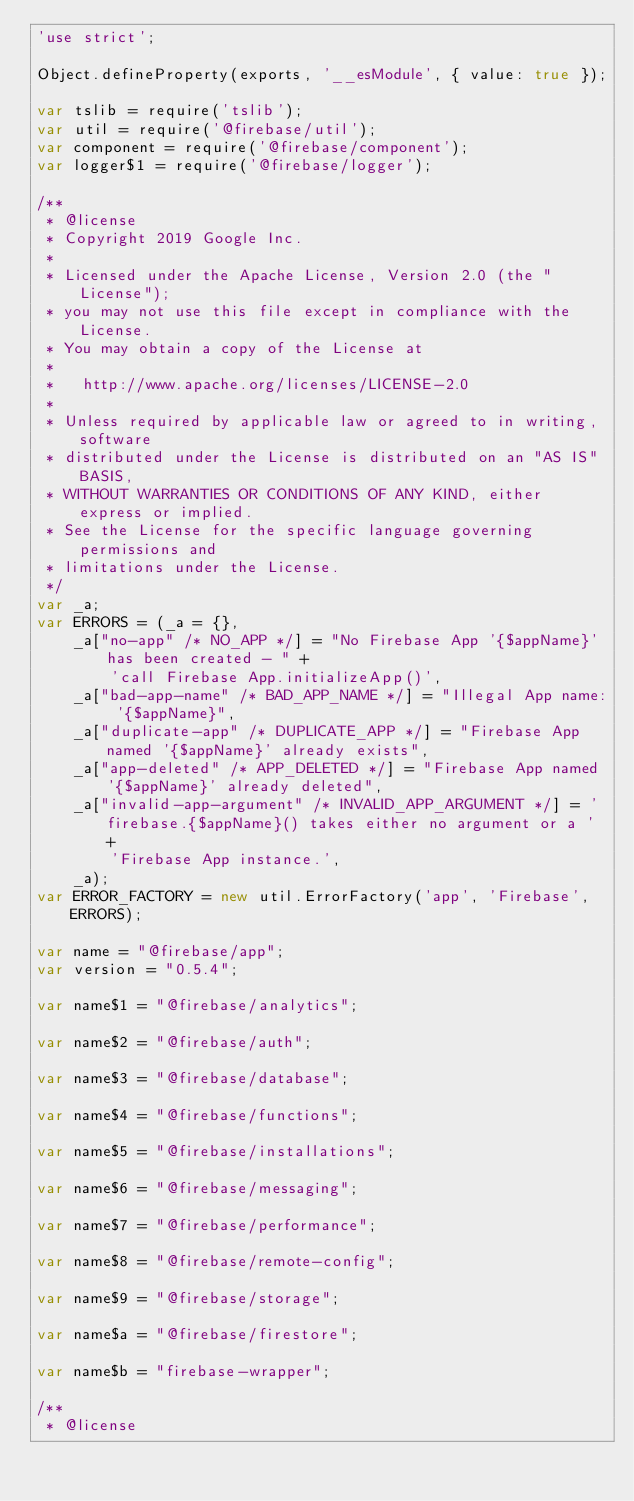<code> <loc_0><loc_0><loc_500><loc_500><_JavaScript_>'use strict';

Object.defineProperty(exports, '__esModule', { value: true });

var tslib = require('tslib');
var util = require('@firebase/util');
var component = require('@firebase/component');
var logger$1 = require('@firebase/logger');

/**
 * @license
 * Copyright 2019 Google Inc.
 *
 * Licensed under the Apache License, Version 2.0 (the "License");
 * you may not use this file except in compliance with the License.
 * You may obtain a copy of the License at
 *
 *   http://www.apache.org/licenses/LICENSE-2.0
 *
 * Unless required by applicable law or agreed to in writing, software
 * distributed under the License is distributed on an "AS IS" BASIS,
 * WITHOUT WARRANTIES OR CONDITIONS OF ANY KIND, either express or implied.
 * See the License for the specific language governing permissions and
 * limitations under the License.
 */
var _a;
var ERRORS = (_a = {},
    _a["no-app" /* NO_APP */] = "No Firebase App '{$appName}' has been created - " +
        'call Firebase App.initializeApp()',
    _a["bad-app-name" /* BAD_APP_NAME */] = "Illegal App name: '{$appName}",
    _a["duplicate-app" /* DUPLICATE_APP */] = "Firebase App named '{$appName}' already exists",
    _a["app-deleted" /* APP_DELETED */] = "Firebase App named '{$appName}' already deleted",
    _a["invalid-app-argument" /* INVALID_APP_ARGUMENT */] = 'firebase.{$appName}() takes either no argument or a ' +
        'Firebase App instance.',
    _a);
var ERROR_FACTORY = new util.ErrorFactory('app', 'Firebase', ERRORS);

var name = "@firebase/app";
var version = "0.5.4";

var name$1 = "@firebase/analytics";

var name$2 = "@firebase/auth";

var name$3 = "@firebase/database";

var name$4 = "@firebase/functions";

var name$5 = "@firebase/installations";

var name$6 = "@firebase/messaging";

var name$7 = "@firebase/performance";

var name$8 = "@firebase/remote-config";

var name$9 = "@firebase/storage";

var name$a = "@firebase/firestore";

var name$b = "firebase-wrapper";

/**
 * @license</code> 